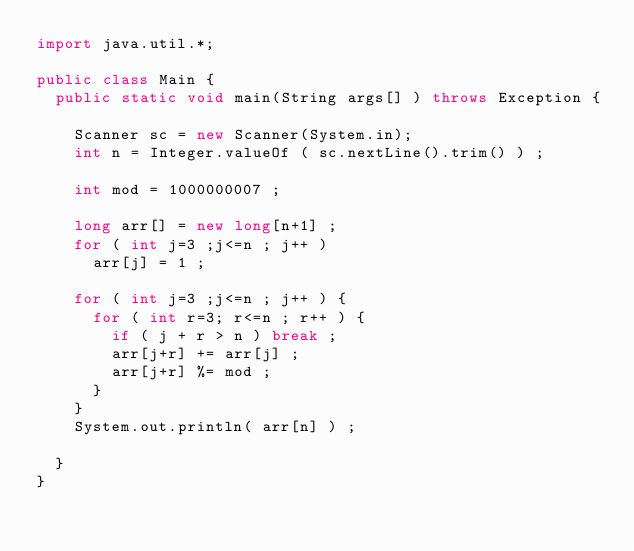<code> <loc_0><loc_0><loc_500><loc_500><_Java_>import java.util.*;
 
public class Main {
	public static void main(String args[] ) throws Exception {

		Scanner sc = new Scanner(System.in);
		int n = Integer.valueOf ( sc.nextLine().trim() ) ;

		int mod = 1000000007 ;

		long arr[] = new long[n+1] ; 
		for ( int j=3 ;j<=n ; j++ )
			arr[j] = 1 ;

		for ( int j=3 ;j<=n ; j++ ) {
			for ( int r=3; r<=n ; r++ ) {
				if ( j + r > n ) break ;
				arr[j+r] += arr[j] ;
				arr[j+r] %= mod ;
			}
		}
		System.out.println( arr[n] ) ;

	}
}</code> 